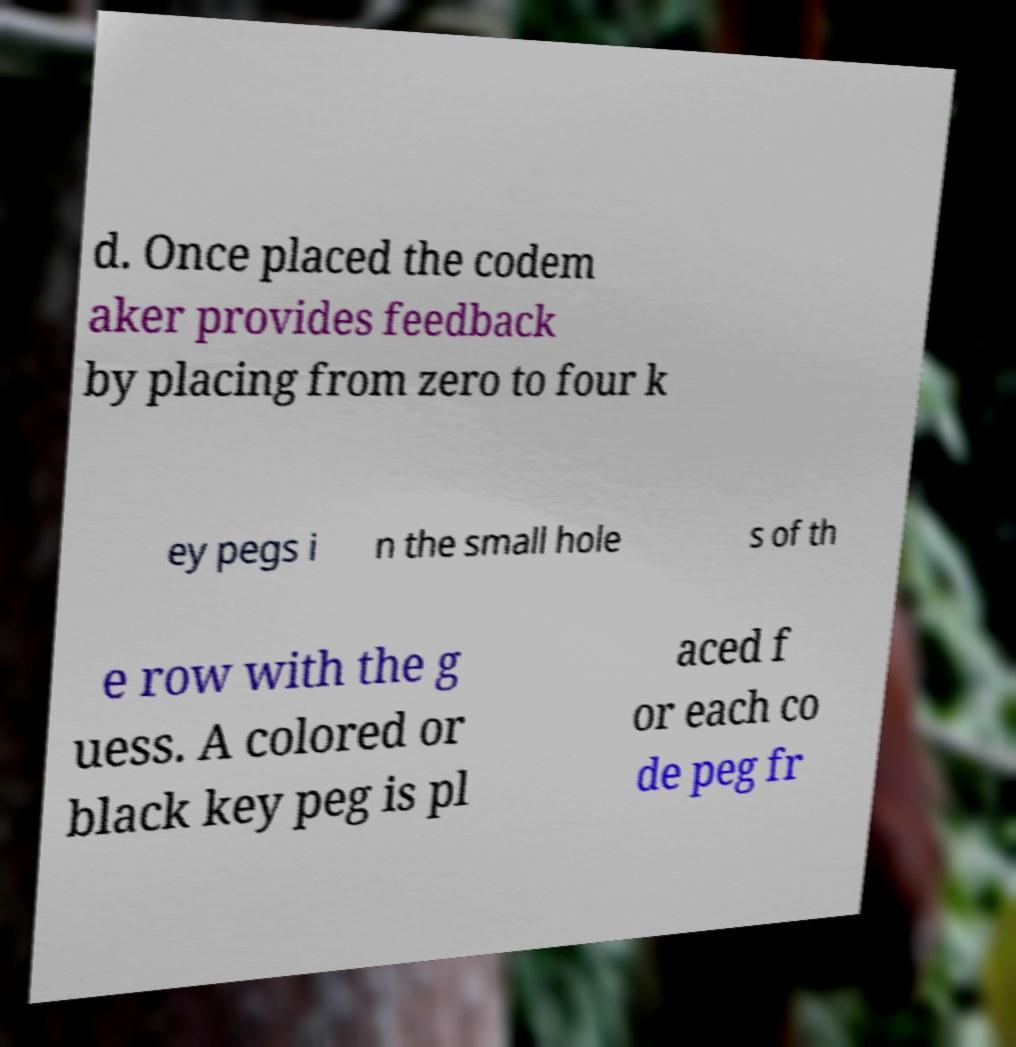What messages or text are displayed in this image? I need them in a readable, typed format. d. Once placed the codem aker provides feedback by placing from zero to four k ey pegs i n the small hole s of th e row with the g uess. A colored or black key peg is pl aced f or each co de peg fr 